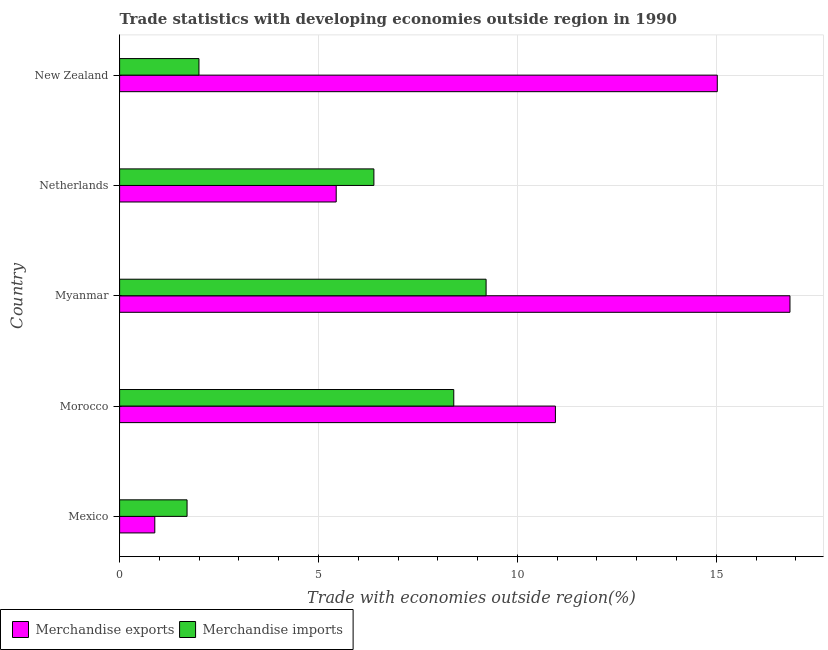How many different coloured bars are there?
Provide a short and direct response. 2. Are the number of bars on each tick of the Y-axis equal?
Your answer should be very brief. Yes. How many bars are there on the 1st tick from the bottom?
Provide a short and direct response. 2. What is the label of the 2nd group of bars from the top?
Offer a very short reply. Netherlands. In how many cases, is the number of bars for a given country not equal to the number of legend labels?
Provide a succinct answer. 0. What is the merchandise exports in Mexico?
Offer a very short reply. 0.88. Across all countries, what is the maximum merchandise imports?
Offer a very short reply. 9.21. Across all countries, what is the minimum merchandise imports?
Your answer should be very brief. 1.7. In which country was the merchandise exports maximum?
Your answer should be compact. Myanmar. In which country was the merchandise imports minimum?
Keep it short and to the point. Mexico. What is the total merchandise imports in the graph?
Ensure brevity in your answer.  27.7. What is the difference between the merchandise imports in Morocco and that in Myanmar?
Your response must be concise. -0.81. What is the difference between the merchandise exports in Netherlands and the merchandise imports in Myanmar?
Ensure brevity in your answer.  -3.77. What is the average merchandise imports per country?
Offer a terse response. 5.54. What is the difference between the merchandise imports and merchandise exports in Morocco?
Your answer should be compact. -2.56. What is the ratio of the merchandise imports in Myanmar to that in Netherlands?
Provide a short and direct response. 1.44. Is the merchandise imports in Netherlands less than that in New Zealand?
Provide a short and direct response. No. What is the difference between the highest and the second highest merchandise exports?
Provide a succinct answer. 1.83. What is the difference between the highest and the lowest merchandise exports?
Give a very brief answer. 15.97. In how many countries, is the merchandise exports greater than the average merchandise exports taken over all countries?
Keep it short and to the point. 3. What does the 2nd bar from the bottom in Morocco represents?
Offer a terse response. Merchandise imports. How many bars are there?
Make the answer very short. 10. Are all the bars in the graph horizontal?
Provide a short and direct response. Yes. What is the difference between two consecutive major ticks on the X-axis?
Ensure brevity in your answer.  5. Are the values on the major ticks of X-axis written in scientific E-notation?
Keep it short and to the point. No. Does the graph contain grids?
Offer a very short reply. Yes. What is the title of the graph?
Give a very brief answer. Trade statistics with developing economies outside region in 1990. Does "Primary" appear as one of the legend labels in the graph?
Make the answer very short. No. What is the label or title of the X-axis?
Your answer should be very brief. Trade with economies outside region(%). What is the label or title of the Y-axis?
Your answer should be very brief. Country. What is the Trade with economies outside region(%) in Merchandise exports in Mexico?
Your response must be concise. 0.88. What is the Trade with economies outside region(%) in Merchandise imports in Mexico?
Your answer should be compact. 1.7. What is the Trade with economies outside region(%) of Merchandise exports in Morocco?
Provide a short and direct response. 10.96. What is the Trade with economies outside region(%) of Merchandise imports in Morocco?
Provide a short and direct response. 8.4. What is the Trade with economies outside region(%) of Merchandise exports in Myanmar?
Provide a succinct answer. 16.85. What is the Trade with economies outside region(%) in Merchandise imports in Myanmar?
Provide a short and direct response. 9.21. What is the Trade with economies outside region(%) of Merchandise exports in Netherlands?
Ensure brevity in your answer.  5.44. What is the Trade with economies outside region(%) of Merchandise imports in Netherlands?
Offer a very short reply. 6.39. What is the Trade with economies outside region(%) in Merchandise exports in New Zealand?
Offer a terse response. 15.02. What is the Trade with economies outside region(%) of Merchandise imports in New Zealand?
Your answer should be very brief. 1.99. Across all countries, what is the maximum Trade with economies outside region(%) of Merchandise exports?
Your response must be concise. 16.85. Across all countries, what is the maximum Trade with economies outside region(%) of Merchandise imports?
Your response must be concise. 9.21. Across all countries, what is the minimum Trade with economies outside region(%) of Merchandise exports?
Provide a short and direct response. 0.88. Across all countries, what is the minimum Trade with economies outside region(%) of Merchandise imports?
Your answer should be compact. 1.7. What is the total Trade with economies outside region(%) of Merchandise exports in the graph?
Provide a succinct answer. 49.16. What is the total Trade with economies outside region(%) in Merchandise imports in the graph?
Ensure brevity in your answer.  27.7. What is the difference between the Trade with economies outside region(%) in Merchandise exports in Mexico and that in Morocco?
Give a very brief answer. -10.07. What is the difference between the Trade with economies outside region(%) in Merchandise imports in Mexico and that in Morocco?
Your answer should be very brief. -6.7. What is the difference between the Trade with economies outside region(%) in Merchandise exports in Mexico and that in Myanmar?
Your answer should be compact. -15.97. What is the difference between the Trade with economies outside region(%) of Merchandise imports in Mexico and that in Myanmar?
Ensure brevity in your answer.  -7.52. What is the difference between the Trade with economies outside region(%) in Merchandise exports in Mexico and that in Netherlands?
Make the answer very short. -4.56. What is the difference between the Trade with economies outside region(%) in Merchandise imports in Mexico and that in Netherlands?
Ensure brevity in your answer.  -4.7. What is the difference between the Trade with economies outside region(%) of Merchandise exports in Mexico and that in New Zealand?
Keep it short and to the point. -14.14. What is the difference between the Trade with economies outside region(%) in Merchandise imports in Mexico and that in New Zealand?
Ensure brevity in your answer.  -0.3. What is the difference between the Trade with economies outside region(%) of Merchandise exports in Morocco and that in Myanmar?
Ensure brevity in your answer.  -5.9. What is the difference between the Trade with economies outside region(%) of Merchandise imports in Morocco and that in Myanmar?
Keep it short and to the point. -0.81. What is the difference between the Trade with economies outside region(%) in Merchandise exports in Morocco and that in Netherlands?
Your response must be concise. 5.51. What is the difference between the Trade with economies outside region(%) in Merchandise imports in Morocco and that in Netherlands?
Offer a terse response. 2.01. What is the difference between the Trade with economies outside region(%) of Merchandise exports in Morocco and that in New Zealand?
Make the answer very short. -4.07. What is the difference between the Trade with economies outside region(%) in Merchandise imports in Morocco and that in New Zealand?
Provide a succinct answer. 6.41. What is the difference between the Trade with economies outside region(%) of Merchandise exports in Myanmar and that in Netherlands?
Provide a short and direct response. 11.41. What is the difference between the Trade with economies outside region(%) of Merchandise imports in Myanmar and that in Netherlands?
Your answer should be compact. 2.82. What is the difference between the Trade with economies outside region(%) in Merchandise exports in Myanmar and that in New Zealand?
Provide a short and direct response. 1.83. What is the difference between the Trade with economies outside region(%) in Merchandise imports in Myanmar and that in New Zealand?
Your answer should be compact. 7.22. What is the difference between the Trade with economies outside region(%) of Merchandise exports in Netherlands and that in New Zealand?
Your response must be concise. -9.58. What is the difference between the Trade with economies outside region(%) of Merchandise imports in Netherlands and that in New Zealand?
Provide a short and direct response. 4.4. What is the difference between the Trade with economies outside region(%) in Merchandise exports in Mexico and the Trade with economies outside region(%) in Merchandise imports in Morocco?
Your response must be concise. -7.52. What is the difference between the Trade with economies outside region(%) of Merchandise exports in Mexico and the Trade with economies outside region(%) of Merchandise imports in Myanmar?
Provide a succinct answer. -8.33. What is the difference between the Trade with economies outside region(%) in Merchandise exports in Mexico and the Trade with economies outside region(%) in Merchandise imports in Netherlands?
Provide a succinct answer. -5.51. What is the difference between the Trade with economies outside region(%) in Merchandise exports in Mexico and the Trade with economies outside region(%) in Merchandise imports in New Zealand?
Your answer should be very brief. -1.11. What is the difference between the Trade with economies outside region(%) of Merchandise exports in Morocco and the Trade with economies outside region(%) of Merchandise imports in Myanmar?
Offer a very short reply. 1.74. What is the difference between the Trade with economies outside region(%) of Merchandise exports in Morocco and the Trade with economies outside region(%) of Merchandise imports in Netherlands?
Your answer should be compact. 4.56. What is the difference between the Trade with economies outside region(%) in Merchandise exports in Morocco and the Trade with economies outside region(%) in Merchandise imports in New Zealand?
Keep it short and to the point. 8.96. What is the difference between the Trade with economies outside region(%) of Merchandise exports in Myanmar and the Trade with economies outside region(%) of Merchandise imports in Netherlands?
Make the answer very short. 10.46. What is the difference between the Trade with economies outside region(%) of Merchandise exports in Myanmar and the Trade with economies outside region(%) of Merchandise imports in New Zealand?
Make the answer very short. 14.86. What is the difference between the Trade with economies outside region(%) in Merchandise exports in Netherlands and the Trade with economies outside region(%) in Merchandise imports in New Zealand?
Give a very brief answer. 3.45. What is the average Trade with economies outside region(%) of Merchandise exports per country?
Ensure brevity in your answer.  9.83. What is the average Trade with economies outside region(%) of Merchandise imports per country?
Your response must be concise. 5.54. What is the difference between the Trade with economies outside region(%) of Merchandise exports and Trade with economies outside region(%) of Merchandise imports in Mexico?
Your answer should be very brief. -0.81. What is the difference between the Trade with economies outside region(%) of Merchandise exports and Trade with economies outside region(%) of Merchandise imports in Morocco?
Offer a terse response. 2.55. What is the difference between the Trade with economies outside region(%) in Merchandise exports and Trade with economies outside region(%) in Merchandise imports in Myanmar?
Your answer should be compact. 7.64. What is the difference between the Trade with economies outside region(%) in Merchandise exports and Trade with economies outside region(%) in Merchandise imports in Netherlands?
Give a very brief answer. -0.95. What is the difference between the Trade with economies outside region(%) of Merchandise exports and Trade with economies outside region(%) of Merchandise imports in New Zealand?
Give a very brief answer. 13.03. What is the ratio of the Trade with economies outside region(%) in Merchandise exports in Mexico to that in Morocco?
Your answer should be very brief. 0.08. What is the ratio of the Trade with economies outside region(%) in Merchandise imports in Mexico to that in Morocco?
Provide a short and direct response. 0.2. What is the ratio of the Trade with economies outside region(%) in Merchandise exports in Mexico to that in Myanmar?
Your answer should be very brief. 0.05. What is the ratio of the Trade with economies outside region(%) of Merchandise imports in Mexico to that in Myanmar?
Provide a short and direct response. 0.18. What is the ratio of the Trade with economies outside region(%) in Merchandise exports in Mexico to that in Netherlands?
Your answer should be very brief. 0.16. What is the ratio of the Trade with economies outside region(%) in Merchandise imports in Mexico to that in Netherlands?
Your answer should be compact. 0.27. What is the ratio of the Trade with economies outside region(%) of Merchandise exports in Mexico to that in New Zealand?
Offer a terse response. 0.06. What is the ratio of the Trade with economies outside region(%) of Merchandise imports in Mexico to that in New Zealand?
Your answer should be very brief. 0.85. What is the ratio of the Trade with economies outside region(%) of Merchandise exports in Morocco to that in Myanmar?
Your answer should be very brief. 0.65. What is the ratio of the Trade with economies outside region(%) of Merchandise imports in Morocco to that in Myanmar?
Your response must be concise. 0.91. What is the ratio of the Trade with economies outside region(%) in Merchandise exports in Morocco to that in Netherlands?
Provide a short and direct response. 2.01. What is the ratio of the Trade with economies outside region(%) in Merchandise imports in Morocco to that in Netherlands?
Your response must be concise. 1.31. What is the ratio of the Trade with economies outside region(%) of Merchandise exports in Morocco to that in New Zealand?
Your response must be concise. 0.73. What is the ratio of the Trade with economies outside region(%) in Merchandise imports in Morocco to that in New Zealand?
Offer a terse response. 4.21. What is the ratio of the Trade with economies outside region(%) in Merchandise exports in Myanmar to that in Netherlands?
Offer a very short reply. 3.1. What is the ratio of the Trade with economies outside region(%) in Merchandise imports in Myanmar to that in Netherlands?
Give a very brief answer. 1.44. What is the ratio of the Trade with economies outside region(%) of Merchandise exports in Myanmar to that in New Zealand?
Provide a succinct answer. 1.12. What is the ratio of the Trade with economies outside region(%) of Merchandise imports in Myanmar to that in New Zealand?
Offer a very short reply. 4.62. What is the ratio of the Trade with economies outside region(%) of Merchandise exports in Netherlands to that in New Zealand?
Your response must be concise. 0.36. What is the ratio of the Trade with economies outside region(%) in Merchandise imports in Netherlands to that in New Zealand?
Your answer should be very brief. 3.2. What is the difference between the highest and the second highest Trade with economies outside region(%) in Merchandise exports?
Keep it short and to the point. 1.83. What is the difference between the highest and the second highest Trade with economies outside region(%) of Merchandise imports?
Keep it short and to the point. 0.81. What is the difference between the highest and the lowest Trade with economies outside region(%) in Merchandise exports?
Keep it short and to the point. 15.97. What is the difference between the highest and the lowest Trade with economies outside region(%) of Merchandise imports?
Make the answer very short. 7.52. 